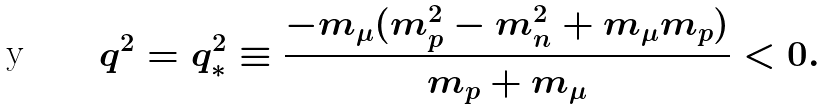Convert formula to latex. <formula><loc_0><loc_0><loc_500><loc_500>q ^ { 2 } = q _ { * } ^ { 2 } \equiv \frac { - m _ { \mu } ( m _ { p } ^ { 2 } - m _ { n } ^ { 2 } + m _ { \mu } m _ { p } ) } { m _ { p } + m _ { \mu } } < 0 .</formula> 